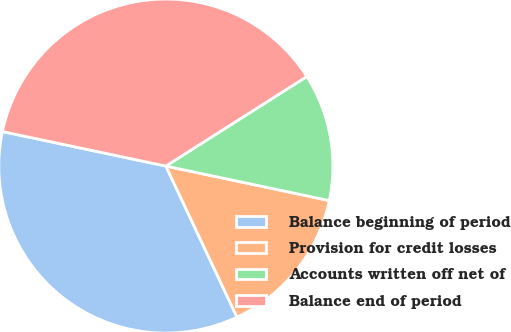Convert chart to OTSL. <chart><loc_0><loc_0><loc_500><loc_500><pie_chart><fcel>Balance beginning of period<fcel>Provision for credit losses<fcel>Accounts written off net of<fcel>Balance end of period<nl><fcel>35.32%<fcel>14.68%<fcel>12.32%<fcel>37.68%<nl></chart> 